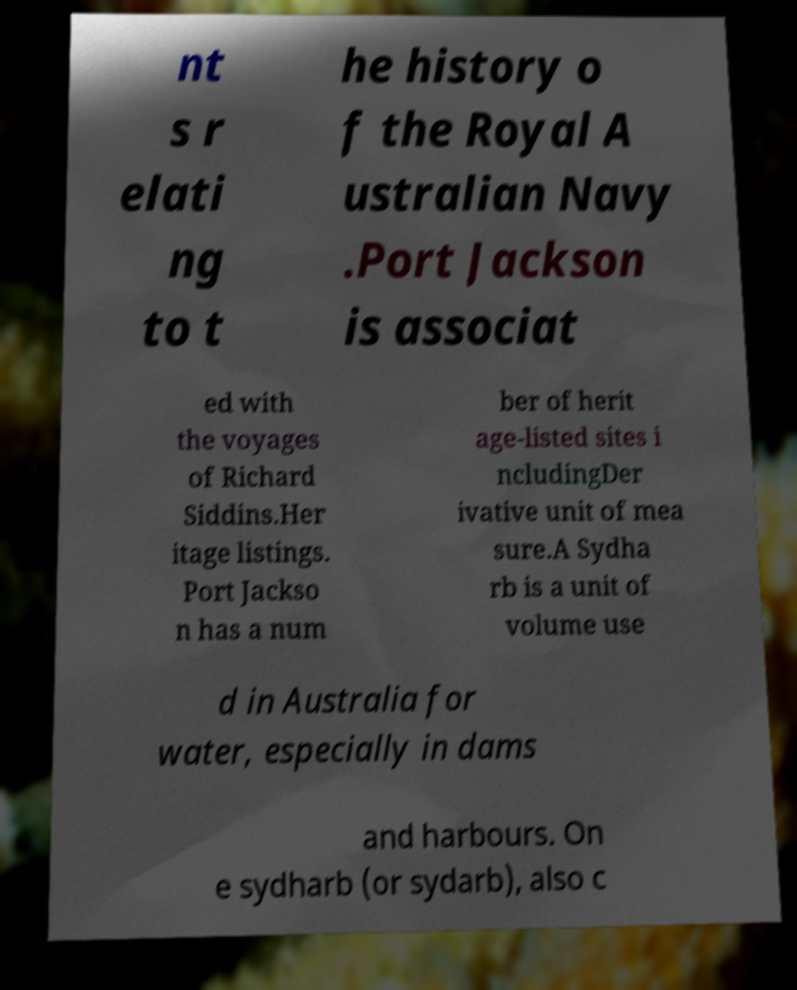I need the written content from this picture converted into text. Can you do that? nt s r elati ng to t he history o f the Royal A ustralian Navy .Port Jackson is associat ed with the voyages of Richard Siddins.Her itage listings. Port Jackso n has a num ber of herit age-listed sites i ncludingDer ivative unit of mea sure.A Sydha rb is a unit of volume use d in Australia for water, especially in dams and harbours. On e sydharb (or sydarb), also c 